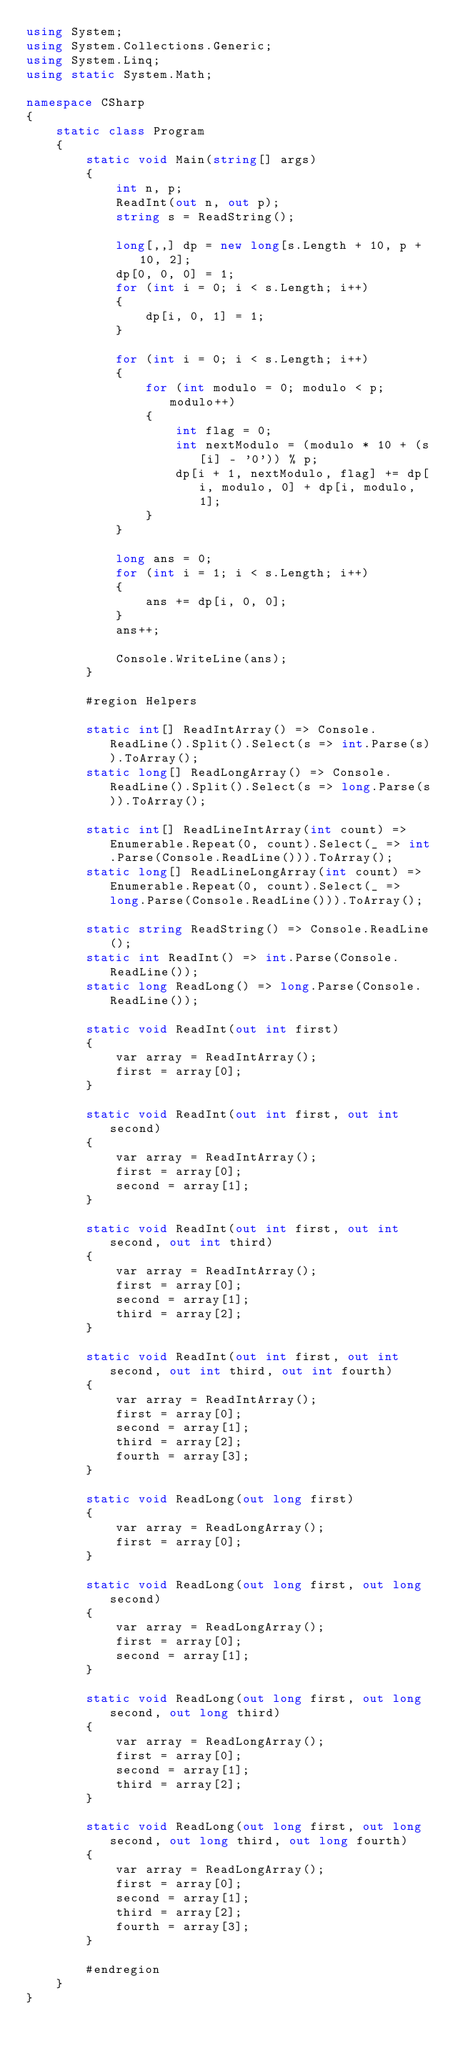Convert code to text. <code><loc_0><loc_0><loc_500><loc_500><_C#_>using System;
using System.Collections.Generic;
using System.Linq;
using static System.Math;

namespace CSharp
{
    static class Program
    {
        static void Main(string[] args)
        {
            int n, p;
            ReadInt(out n, out p);
            string s = ReadString();

            long[,,] dp = new long[s.Length + 10, p + 10, 2];
            dp[0, 0, 0] = 1;
            for (int i = 0; i < s.Length; i++)
            {
                dp[i, 0, 1] = 1;
            }

            for (int i = 0; i < s.Length; i++)
            {
                for (int modulo = 0; modulo < p; modulo++)
                {
                    int flag = 0;
                    int nextModulo = (modulo * 10 + (s[i] - '0')) % p;
                    dp[i + 1, nextModulo, flag] += dp[i, modulo, 0] + dp[i, modulo, 1];
                }
            }

            long ans = 0;
            for (int i = 1; i < s.Length; i++)
            {
                ans += dp[i, 0, 0];
            }
            ans++;

            Console.WriteLine(ans);
        }

        #region Helpers

        static int[] ReadIntArray() => Console.ReadLine().Split().Select(s => int.Parse(s)).ToArray();
        static long[] ReadLongArray() => Console.ReadLine().Split().Select(s => long.Parse(s)).ToArray();

        static int[] ReadLineIntArray(int count) => Enumerable.Repeat(0, count).Select(_ => int.Parse(Console.ReadLine())).ToArray();
        static long[] ReadLineLongArray(int count) => Enumerable.Repeat(0, count).Select(_ => long.Parse(Console.ReadLine())).ToArray();

        static string ReadString() => Console.ReadLine();
        static int ReadInt() => int.Parse(Console.ReadLine());
        static long ReadLong() => long.Parse(Console.ReadLine());

        static void ReadInt(out int first)
        {
            var array = ReadIntArray();
            first = array[0];
        }

        static void ReadInt(out int first, out int second)
        {
            var array = ReadIntArray();
            first = array[0];
            second = array[1];
        }

        static void ReadInt(out int first, out int second, out int third)
        {
            var array = ReadIntArray();
            first = array[0];
            second = array[1];
            third = array[2];
        }

        static void ReadInt(out int first, out int second, out int third, out int fourth)
        {
            var array = ReadIntArray();
            first = array[0];
            second = array[1];
            third = array[2];
            fourth = array[3];
        }

        static void ReadLong(out long first)
        {
            var array = ReadLongArray();
            first = array[0];
        }

        static void ReadLong(out long first, out long second)
        {
            var array = ReadLongArray();
            first = array[0];
            second = array[1];
        }

        static void ReadLong(out long first, out long second, out long third)
        {
            var array = ReadLongArray();
            first = array[0];
            second = array[1];
            third = array[2];
        }

        static void ReadLong(out long first, out long second, out long third, out long fourth)
        {
            var array = ReadLongArray();
            first = array[0];
            second = array[1];
            third = array[2];
            fourth = array[3];
        }

        #endregion
    }
}</code> 